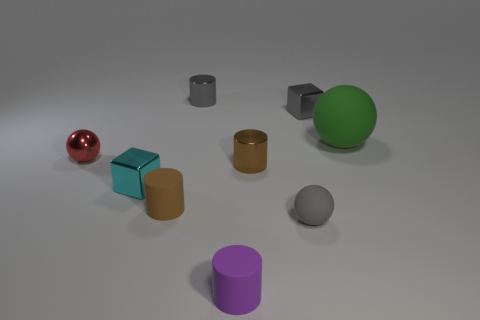Subtract 1 cylinders. How many cylinders are left? 3 Add 1 brown matte cylinders. How many objects exist? 10 Subtract all cyan balls. Subtract all brown blocks. How many balls are left? 3 Subtract all cubes. How many objects are left? 7 Subtract all gray spheres. Subtract all tiny gray metal blocks. How many objects are left? 7 Add 3 tiny gray matte things. How many tiny gray matte things are left? 4 Add 4 big yellow things. How many big yellow things exist? 4 Subtract 1 gray cylinders. How many objects are left? 8 